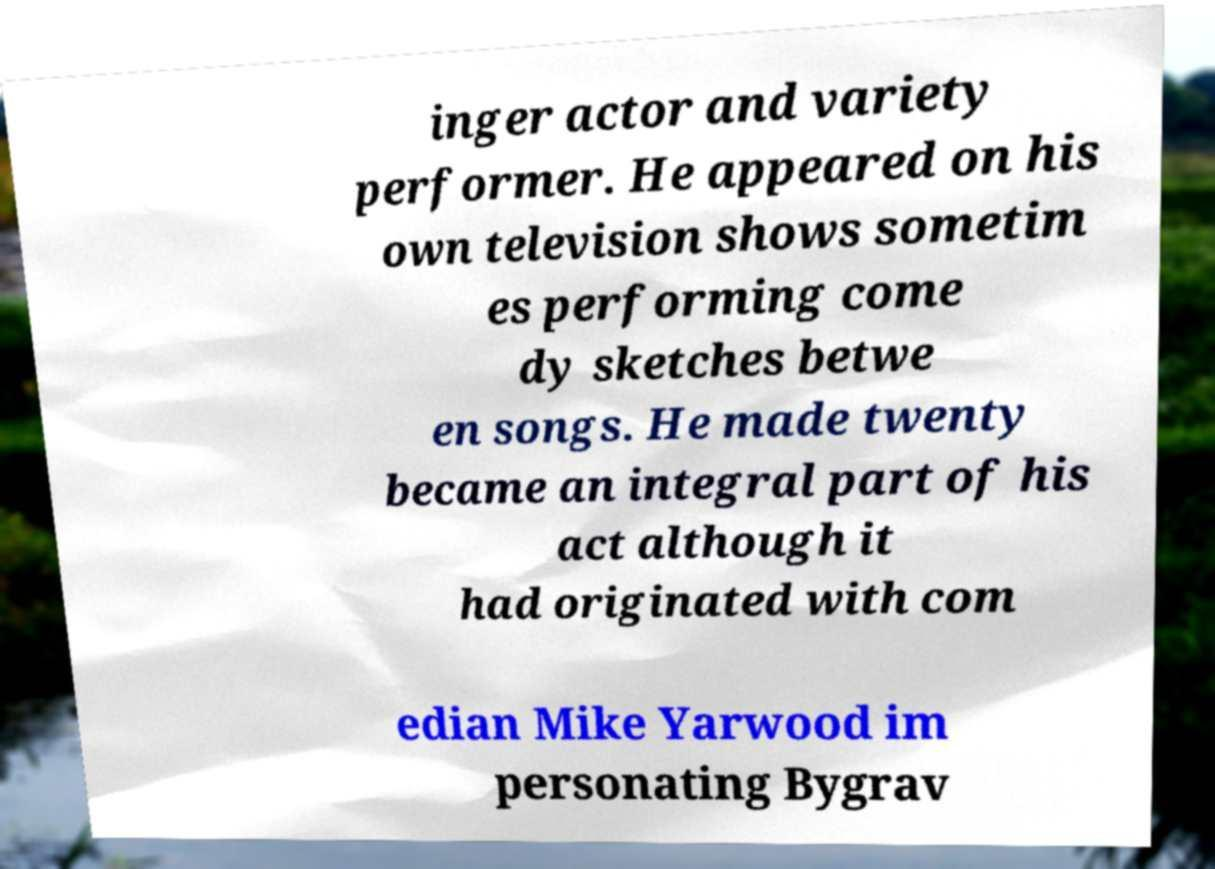Please identify and transcribe the text found in this image. inger actor and variety performer. He appeared on his own television shows sometim es performing come dy sketches betwe en songs. He made twenty became an integral part of his act although it had originated with com edian Mike Yarwood im personating Bygrav 